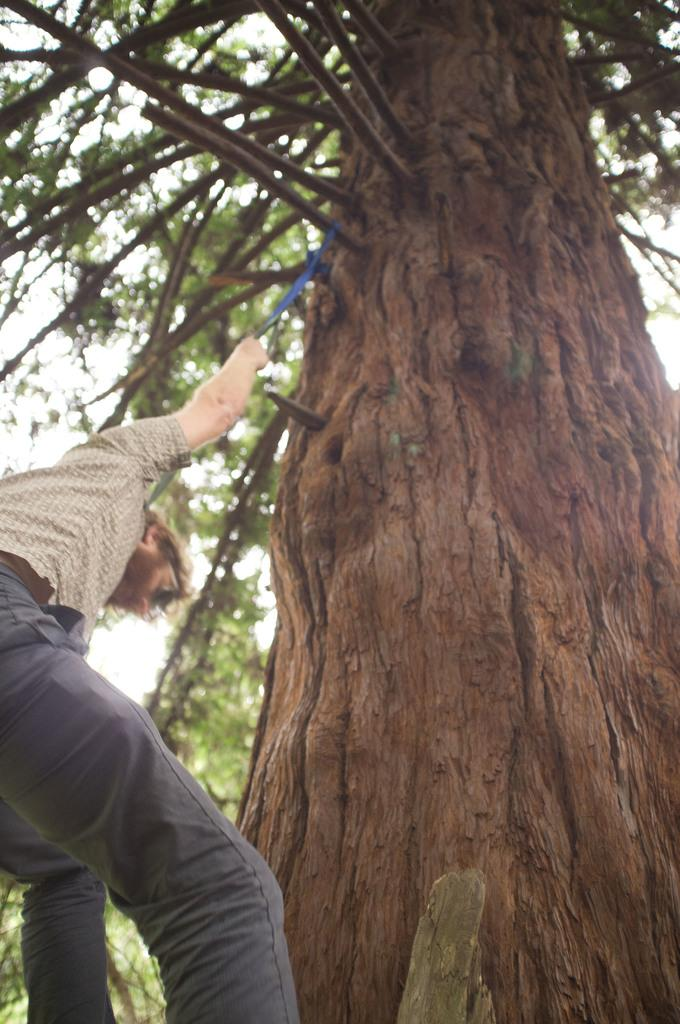Who is present in the image? There is a man in the image. What is the man holding in his hand? The man is holding a rope in his hand. What type of natural environment can be seen in the image? There are trees in the image. What is visible in the background of the image? The sky is visible in the background of the image. What type of paste is the man using to climb the trees in the image? There is no paste present in the image, and the man is not climbing any trees. 